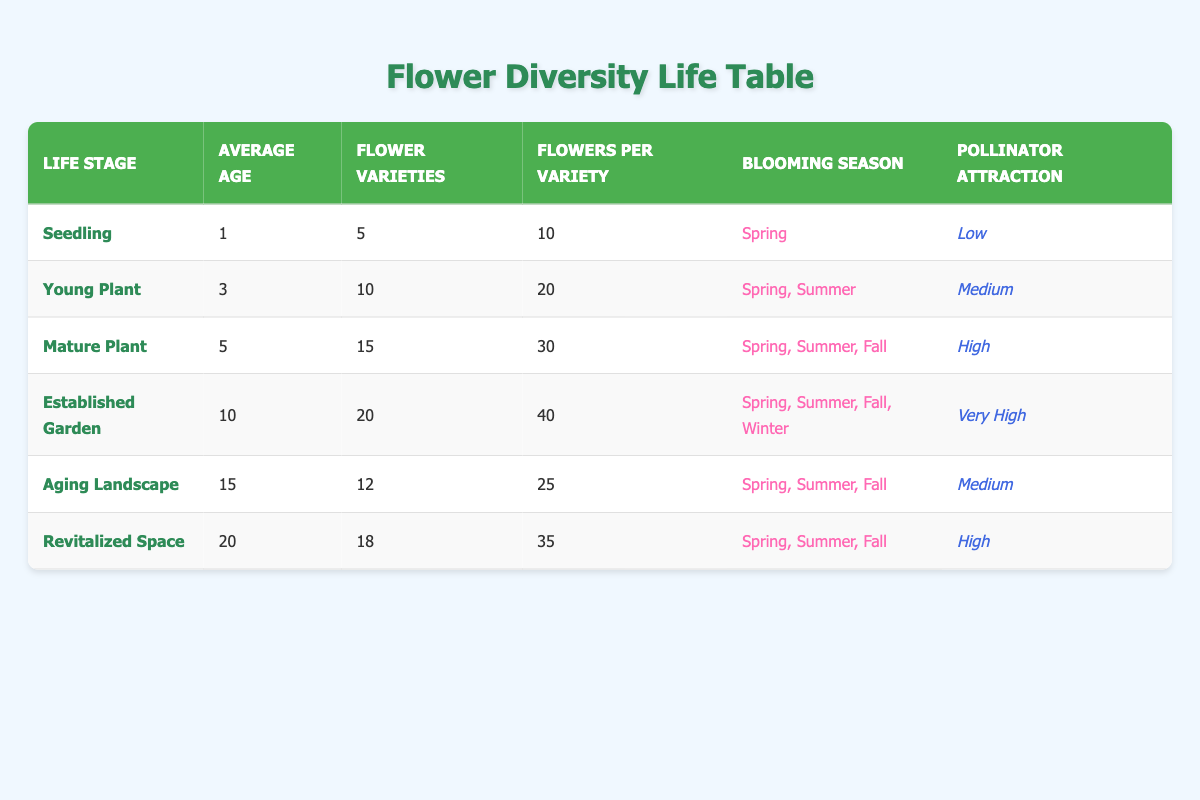What is the flower variety count for a mature plant? The table shows that the mature plant stage has 15 flower varieties listed under the corresponding column.
Answer: 15 During which blooming season do seedlings typically bloom? According to the table, seedlings bloom in the Spring, as indicated in the blooming season column for this life stage.
Answer: Spring What is the average age of an established garden? The table indicates that the established garden life stage has an average age of 10 years listed in the average age column.
Answer: 10 How many total flowers are produced by each flower variety in an aging landscape? The table shows that an aging landscape has 12 flower varieties and each variety produces 25 flowers. Therefore, the total is 12 * 25 = 300 flowers.
Answer: 300 Is the pollinator attraction level for a young plant high? The table states that the pollinator attraction for a young plant is categorized as medium, so the answer is no.
Answer: No What is the difference in flower varieties between the established garden and the aging landscape stages? From the table, the established garden has 20 flower varieties, while the aging landscape has 12. Therefore, the difference is 20 - 12 = 8 flower varieties.
Answer: 8 During which life stage is the pollinator attraction at its peak? The table indicates that the established garden has the highest pollinator attraction level, categorized as very high, compared to others.
Answer: Established Garden In what life stage does flower diversity decrease compared to the previous stage? Moving from the established garden (20 varieties) to the aging landscape (12 varieties) shows a decrease in diversity.
Answer: Aging Landscape How many total flowers are there in a revitalized space? A revitalized space has 18 flower varieties, with each producing 35 flowers. Therefore, total flowers are calculated by 18 * 35 = 630.
Answer: 630 